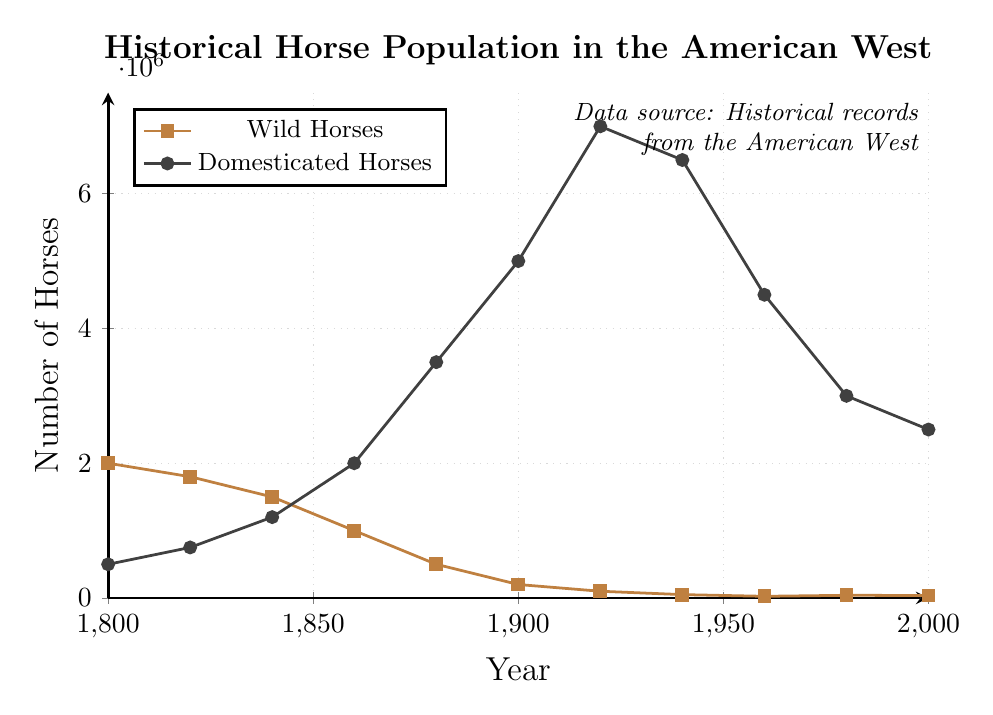What's the average number of wild horses in the years provided? To calculate the average, sum all the wild horse population values: 2000000 + 1800000 + 1500000 + 1000000 + 500000 + 200000 + 100000 + 50000 + 25000 + 40000 + 37000 = 6070000. Then divide by the number of data points, which is 11. So, the average is 6070000 / 11 ≈ 552727.27
Answer: 552727.27 In which year did domesticated horses surpass wild horses? Compare the two populations year by year. In 1860, domesticated horses (2000000) were greater than wild horses (1000000) for the first time.
Answer: 1860 Which year had the highest number of domesticated horses? Examine the line for domesticated horses; the peak value (7000000) occurs in 1920.
Answer: 1920 In which year was the difference between the wild and domesticated horse populations the greatest? Calculate the differences for each year: 1800: 1500000, 1820: 1050000, 1840: 300000, 1860: 1000000, 1880: 3000000, 1900: 4800000, 1920: 6900000, 1940: 6450000, 1960: 4475000, 1980: 2960000, 2000: 2463000. The greatest difference is in 1920 (6900000).
Answer: 1920 Describe the trend of wild horses’ population from 1800 to 2000 The wild horse population shows a general decline from 2000000 in 1800 to 37000 in 2000.
Answer: Decline Compare the number of wild and domesticated horses in 1940 In 1940, the wild horse population was 50000 and the domesticated horse population was 6500000.
Answer: Wild: 50000, Domesticated: 6500000 By how many horses did the domesticated population increase between 1800 and 1920? Subtract the 1800 value (500000) from the 1920 value (7000000): 7000000 - 500000 = 6500000.
Answer: 6500000 What visual feature indicates the population increase in domesticated horses? The slope of the domesticated horses line is upwards, indicating an increase.
Answer: Upward slope Which type of horse saw a more rapid decline after 1900? After 1900, the wild horse population dropped more rapidly compared to domesticated horses, as visually indicated by the steeper slope of the wild horse line.
Answer: Wild horses What is the total population of horses (wild and domesticated combined) in 1980? Add the populations of wild (40000) and domesticated horses (3000000) in 1980: 40000 + 3000000 = 3040000.
Answer: 3040000 